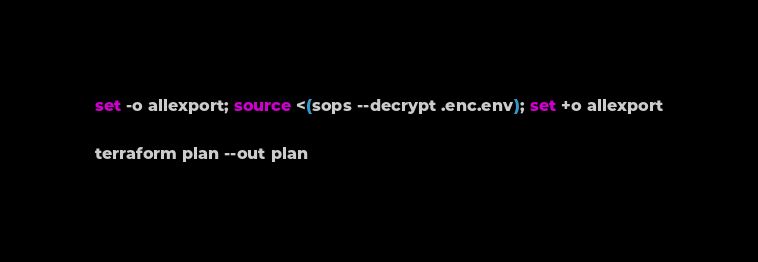Convert code to text. <code><loc_0><loc_0><loc_500><loc_500><_Bash_>set -o allexport; source <(sops --decrypt .enc.env); set +o allexport

terraform plan --out plan
</code> 